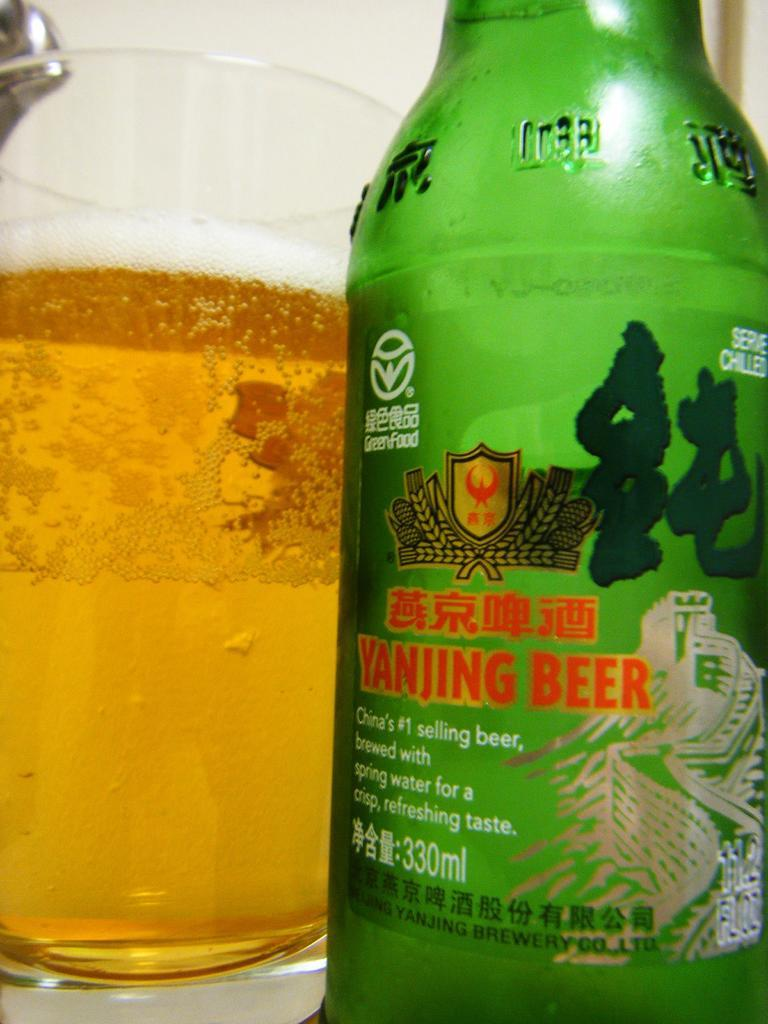<image>
Give a short and clear explanation of the subsequent image. a bottle of Asian beer and a glass of beer next to it. 